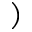Convert formula to latex. <formula><loc_0><loc_0><loc_500><loc_500>)</formula> 